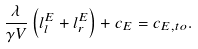<formula> <loc_0><loc_0><loc_500><loc_500>\frac { \lambda } { \gamma V } \left ( l _ { l } ^ { E } + l _ { r } ^ { E } \right ) + c _ { E } = c _ { E , t o } .</formula> 